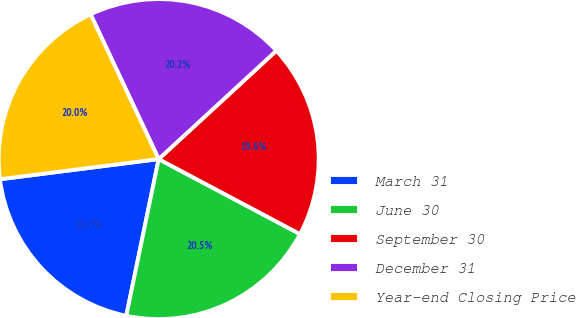Convert chart. <chart><loc_0><loc_0><loc_500><loc_500><pie_chart><fcel>March 31<fcel>June 30<fcel>September 30<fcel>December 31<fcel>Year-end Closing Price<nl><fcel>19.74%<fcel>20.48%<fcel>19.61%<fcel>20.15%<fcel>20.01%<nl></chart> 